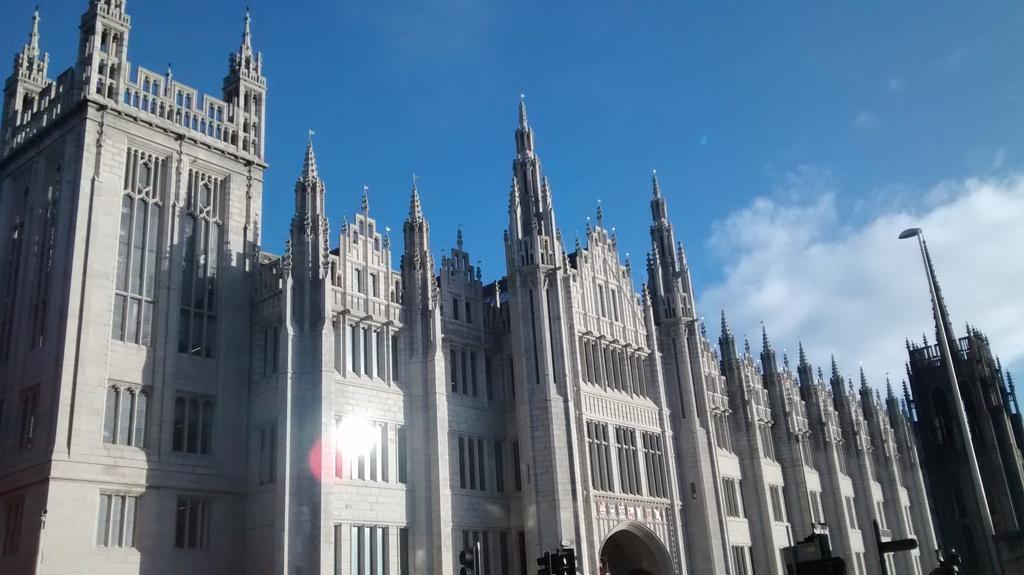Please provide a concise description of this image. This image is clicked outside. There is building in the middle. There is sky at the top. 